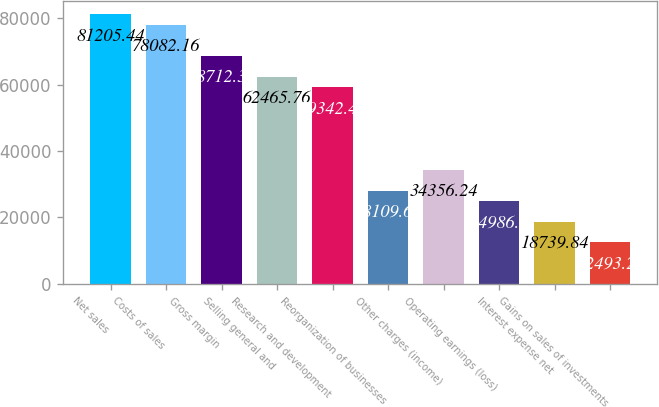Convert chart. <chart><loc_0><loc_0><loc_500><loc_500><bar_chart><fcel>Net sales<fcel>Costs of sales<fcel>Gross margin<fcel>Selling general and<fcel>Research and development<fcel>Reorganization of businesses<fcel>Other charges (income)<fcel>Operating earnings (loss)<fcel>Interest expense net<fcel>Gains on sales of investments<nl><fcel>81205.4<fcel>78082.2<fcel>68712.3<fcel>62465.8<fcel>59342.5<fcel>28109.7<fcel>34356.2<fcel>24986.4<fcel>18739.8<fcel>12493.3<nl></chart> 